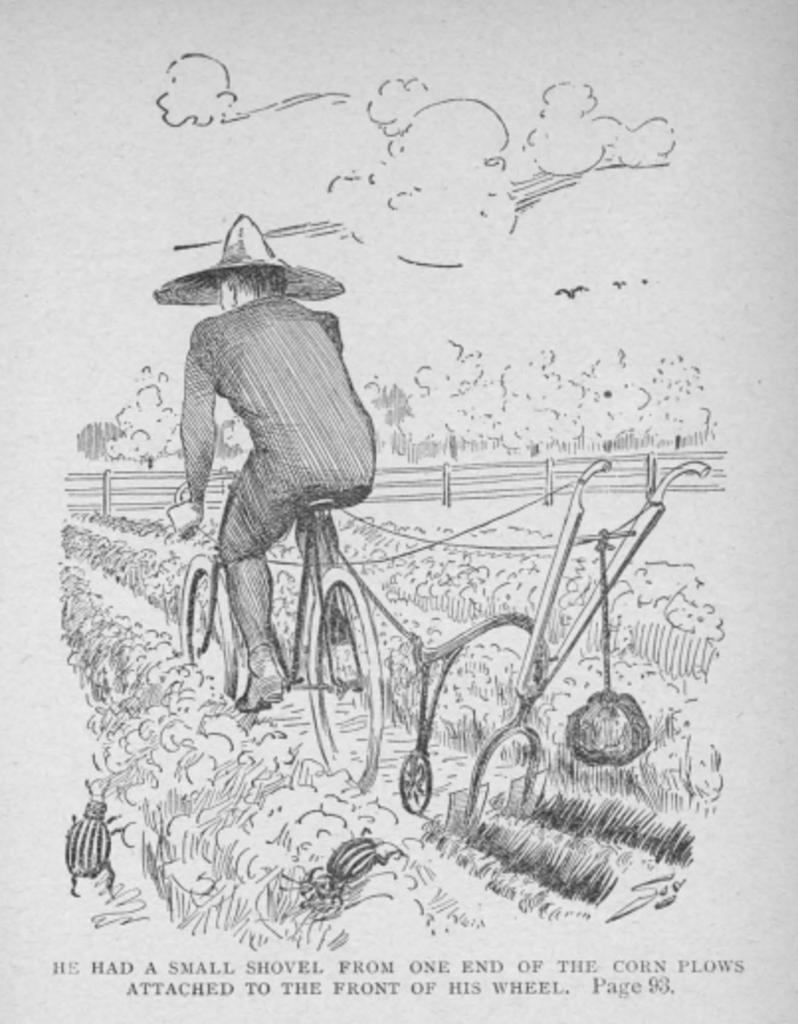In one or two sentences, can you explain what this image depicts? In the foreground of this picture, there is a sketch of the person riding cycle on the path and on either sides there are plants, trees, railing, sky and the cloud. 